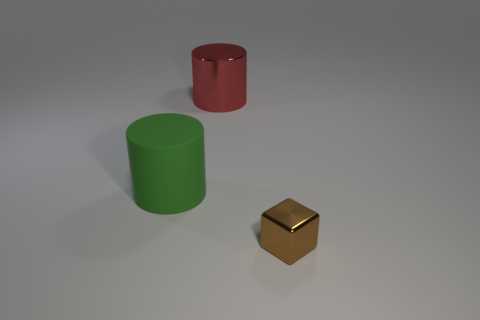Is there anything else that is made of the same material as the green thing?
Your answer should be compact. No. There is another cylinder that is the same size as the shiny cylinder; what color is it?
Offer a terse response. Green. How many things are big cylinders that are in front of the red metallic object or tiny shiny cubes?
Your answer should be compact. 2. There is a small cube that is in front of the metal thing on the left side of the tiny brown shiny thing; what is it made of?
Keep it short and to the point. Metal. Are there any big red cylinders made of the same material as the red thing?
Your answer should be very brief. No. Is there a green rubber thing on the left side of the big cylinder that is in front of the red object?
Your answer should be very brief. No. There is a thing that is on the right side of the red metallic object; what is its material?
Offer a very short reply. Metal. Does the green object have the same shape as the large metallic thing?
Your answer should be very brief. Yes. The metallic thing behind the brown shiny cube that is in front of the shiny thing that is left of the tiny brown shiny block is what color?
Provide a short and direct response. Red. How many tiny brown metal objects have the same shape as the big red thing?
Offer a very short reply. 0. 